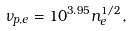Convert formula to latex. <formula><loc_0><loc_0><loc_500><loc_500>\nu _ { p , e } = 1 0 ^ { 3 . 9 5 } n _ { e } ^ { 1 / 2 } ,</formula> 